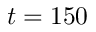Convert formula to latex. <formula><loc_0><loc_0><loc_500><loc_500>t = 1 5 0</formula> 